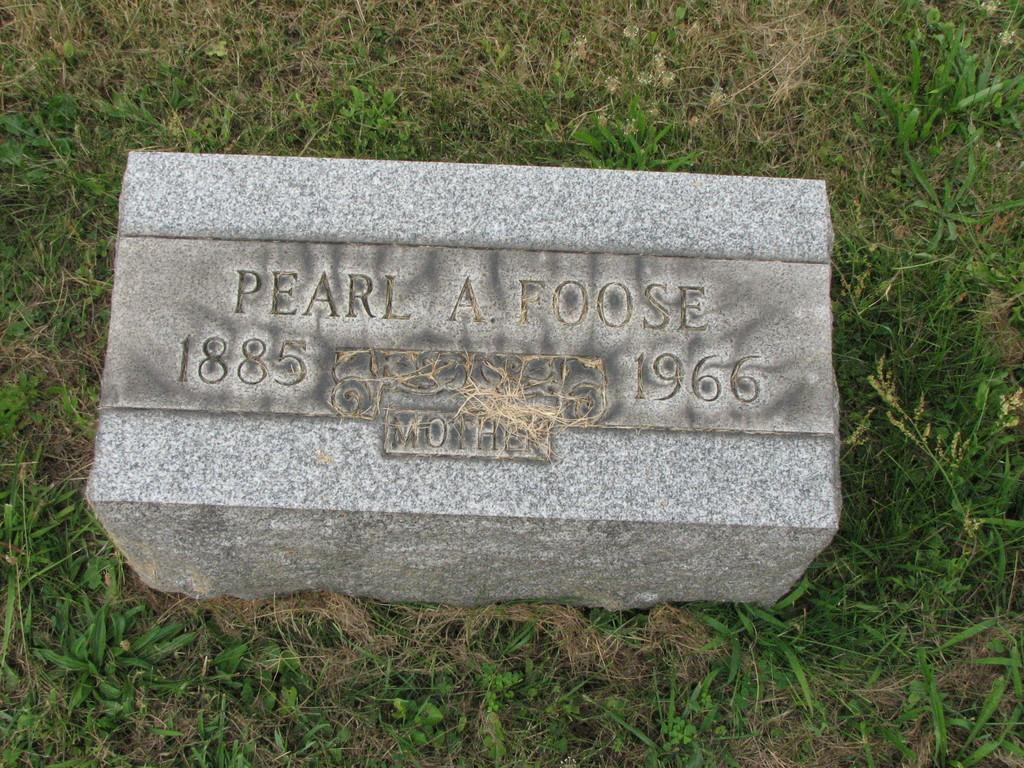What is the main object in the image? There is a stone in the image. Where is the stone located? The stone is on the grass. What can be found on the stone? There is information on the stone. How many grapes are hanging from the stone in the image? There are no grapes present in the image; it features a stone with information on it. What type of trade is being conducted near the stone in the image? There is no trade being conducted in the image; it only shows a stone on the grass with information on it. 